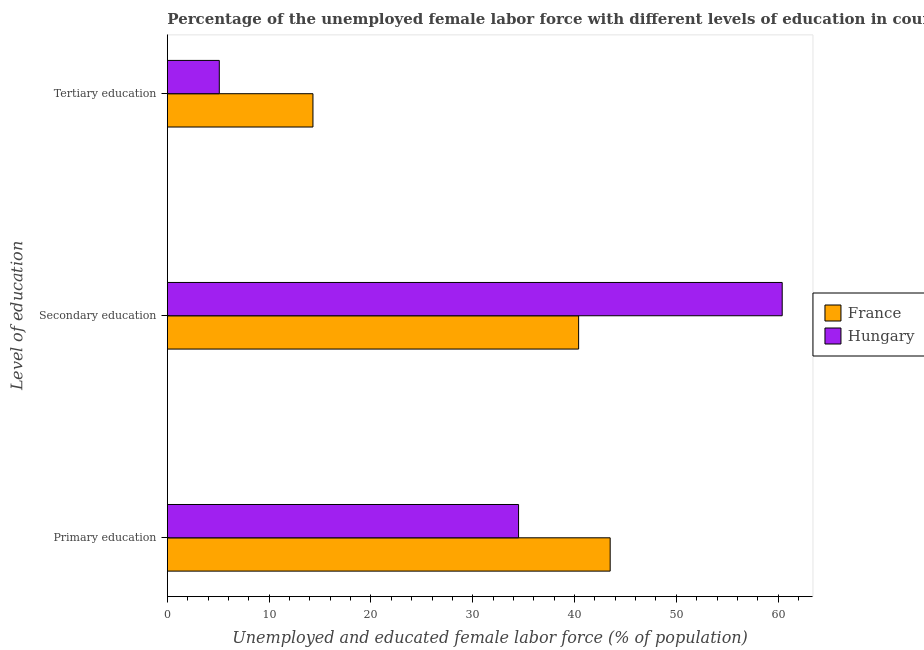Are the number of bars per tick equal to the number of legend labels?
Provide a short and direct response. Yes. How many bars are there on the 3rd tick from the top?
Give a very brief answer. 2. What is the label of the 3rd group of bars from the top?
Make the answer very short. Primary education. What is the percentage of female labor force who received secondary education in Hungary?
Make the answer very short. 60.4. Across all countries, what is the maximum percentage of female labor force who received secondary education?
Provide a short and direct response. 60.4. Across all countries, what is the minimum percentage of female labor force who received primary education?
Your answer should be compact. 34.5. In which country was the percentage of female labor force who received secondary education maximum?
Offer a terse response. Hungary. What is the total percentage of female labor force who received secondary education in the graph?
Provide a short and direct response. 100.8. What is the difference between the percentage of female labor force who received secondary education in France and the percentage of female labor force who received primary education in Hungary?
Offer a very short reply. 5.9. What is the difference between the percentage of female labor force who received tertiary education and percentage of female labor force who received primary education in France?
Make the answer very short. -29.2. What is the ratio of the percentage of female labor force who received tertiary education in Hungary to that in France?
Offer a terse response. 0.36. Is the percentage of female labor force who received primary education in France less than that in Hungary?
Ensure brevity in your answer.  No. Is the difference between the percentage of female labor force who received tertiary education in Hungary and France greater than the difference between the percentage of female labor force who received primary education in Hungary and France?
Your answer should be compact. No. What is the difference between the highest and the second highest percentage of female labor force who received secondary education?
Your response must be concise. 20. What does the 1st bar from the top in Tertiary education represents?
Your response must be concise. Hungary. What does the 2nd bar from the bottom in Primary education represents?
Give a very brief answer. Hungary. How many bars are there?
Keep it short and to the point. 6. What is the difference between two consecutive major ticks on the X-axis?
Your answer should be compact. 10. Are the values on the major ticks of X-axis written in scientific E-notation?
Offer a very short reply. No. Does the graph contain any zero values?
Provide a succinct answer. No. Does the graph contain grids?
Your answer should be very brief. No. Where does the legend appear in the graph?
Your answer should be very brief. Center right. How are the legend labels stacked?
Provide a short and direct response. Vertical. What is the title of the graph?
Your response must be concise. Percentage of the unemployed female labor force with different levels of education in countries. Does "Indonesia" appear as one of the legend labels in the graph?
Provide a succinct answer. No. What is the label or title of the X-axis?
Provide a succinct answer. Unemployed and educated female labor force (% of population). What is the label or title of the Y-axis?
Ensure brevity in your answer.  Level of education. What is the Unemployed and educated female labor force (% of population) in France in Primary education?
Your response must be concise. 43.5. What is the Unemployed and educated female labor force (% of population) of Hungary in Primary education?
Provide a short and direct response. 34.5. What is the Unemployed and educated female labor force (% of population) in France in Secondary education?
Your answer should be compact. 40.4. What is the Unemployed and educated female labor force (% of population) of Hungary in Secondary education?
Ensure brevity in your answer.  60.4. What is the Unemployed and educated female labor force (% of population) in France in Tertiary education?
Provide a succinct answer. 14.3. What is the Unemployed and educated female labor force (% of population) in Hungary in Tertiary education?
Offer a very short reply. 5.1. Across all Level of education, what is the maximum Unemployed and educated female labor force (% of population) of France?
Your answer should be compact. 43.5. Across all Level of education, what is the maximum Unemployed and educated female labor force (% of population) in Hungary?
Your response must be concise. 60.4. Across all Level of education, what is the minimum Unemployed and educated female labor force (% of population) of France?
Provide a short and direct response. 14.3. Across all Level of education, what is the minimum Unemployed and educated female labor force (% of population) of Hungary?
Ensure brevity in your answer.  5.1. What is the total Unemployed and educated female labor force (% of population) of France in the graph?
Give a very brief answer. 98.2. What is the difference between the Unemployed and educated female labor force (% of population) in France in Primary education and that in Secondary education?
Ensure brevity in your answer.  3.1. What is the difference between the Unemployed and educated female labor force (% of population) in Hungary in Primary education and that in Secondary education?
Ensure brevity in your answer.  -25.9. What is the difference between the Unemployed and educated female labor force (% of population) of France in Primary education and that in Tertiary education?
Make the answer very short. 29.2. What is the difference between the Unemployed and educated female labor force (% of population) in Hungary in Primary education and that in Tertiary education?
Your answer should be compact. 29.4. What is the difference between the Unemployed and educated female labor force (% of population) in France in Secondary education and that in Tertiary education?
Your response must be concise. 26.1. What is the difference between the Unemployed and educated female labor force (% of population) in Hungary in Secondary education and that in Tertiary education?
Keep it short and to the point. 55.3. What is the difference between the Unemployed and educated female labor force (% of population) in France in Primary education and the Unemployed and educated female labor force (% of population) in Hungary in Secondary education?
Keep it short and to the point. -16.9. What is the difference between the Unemployed and educated female labor force (% of population) of France in Primary education and the Unemployed and educated female labor force (% of population) of Hungary in Tertiary education?
Ensure brevity in your answer.  38.4. What is the difference between the Unemployed and educated female labor force (% of population) in France in Secondary education and the Unemployed and educated female labor force (% of population) in Hungary in Tertiary education?
Your answer should be very brief. 35.3. What is the average Unemployed and educated female labor force (% of population) of France per Level of education?
Ensure brevity in your answer.  32.73. What is the average Unemployed and educated female labor force (% of population) in Hungary per Level of education?
Provide a short and direct response. 33.33. What is the difference between the Unemployed and educated female labor force (% of population) in France and Unemployed and educated female labor force (% of population) in Hungary in Secondary education?
Offer a terse response. -20. What is the difference between the Unemployed and educated female labor force (% of population) of France and Unemployed and educated female labor force (% of population) of Hungary in Tertiary education?
Keep it short and to the point. 9.2. What is the ratio of the Unemployed and educated female labor force (% of population) of France in Primary education to that in Secondary education?
Your answer should be compact. 1.08. What is the ratio of the Unemployed and educated female labor force (% of population) in Hungary in Primary education to that in Secondary education?
Offer a terse response. 0.57. What is the ratio of the Unemployed and educated female labor force (% of population) in France in Primary education to that in Tertiary education?
Your answer should be compact. 3.04. What is the ratio of the Unemployed and educated female labor force (% of population) of Hungary in Primary education to that in Tertiary education?
Make the answer very short. 6.76. What is the ratio of the Unemployed and educated female labor force (% of population) of France in Secondary education to that in Tertiary education?
Keep it short and to the point. 2.83. What is the ratio of the Unemployed and educated female labor force (% of population) of Hungary in Secondary education to that in Tertiary education?
Keep it short and to the point. 11.84. What is the difference between the highest and the second highest Unemployed and educated female labor force (% of population) in France?
Your answer should be very brief. 3.1. What is the difference between the highest and the second highest Unemployed and educated female labor force (% of population) in Hungary?
Keep it short and to the point. 25.9. What is the difference between the highest and the lowest Unemployed and educated female labor force (% of population) in France?
Ensure brevity in your answer.  29.2. What is the difference between the highest and the lowest Unemployed and educated female labor force (% of population) in Hungary?
Give a very brief answer. 55.3. 